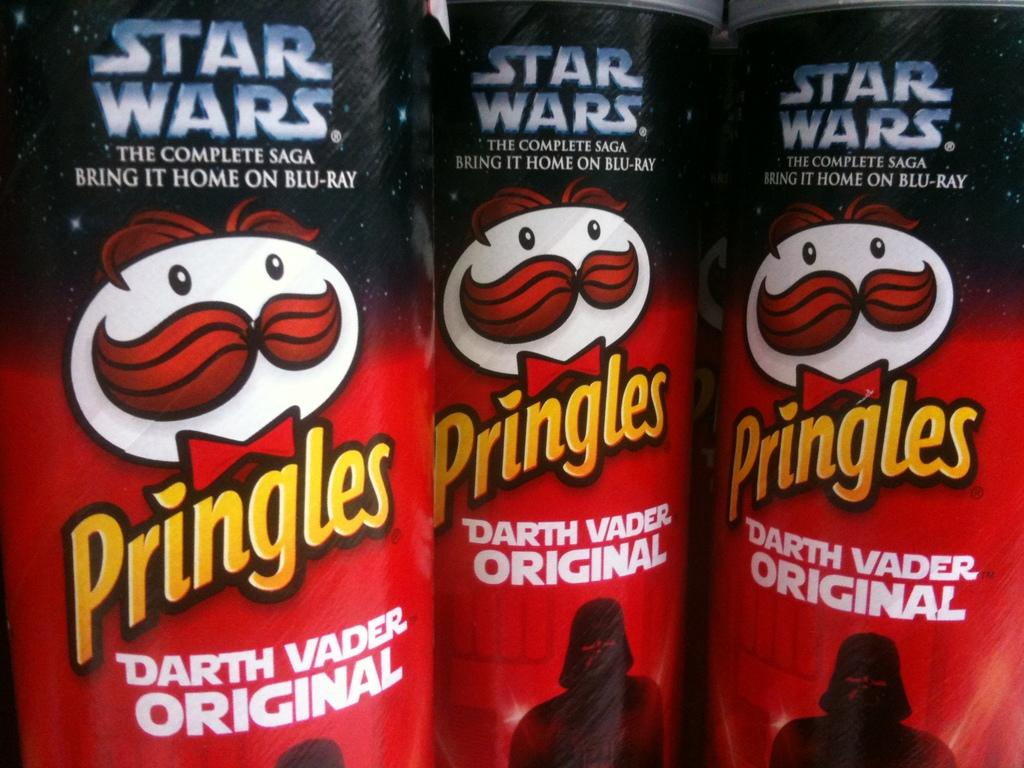<image>
Share a concise interpretation of the image provided. A close up of three Pringle tubes, each is a star wars special editon Darth Vader Original. 